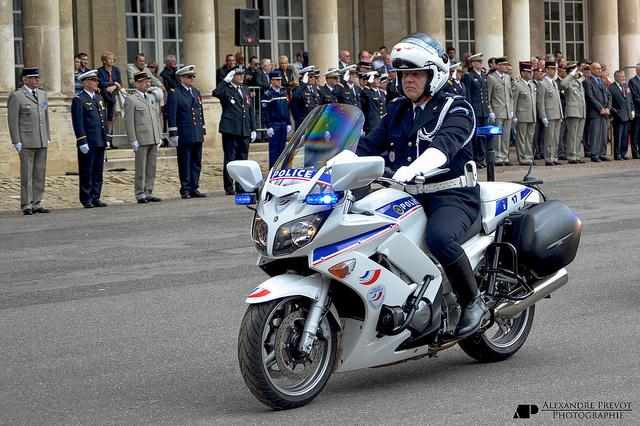Who pays this man's salary? government 